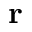<formula> <loc_0><loc_0><loc_500><loc_500>r</formula> 